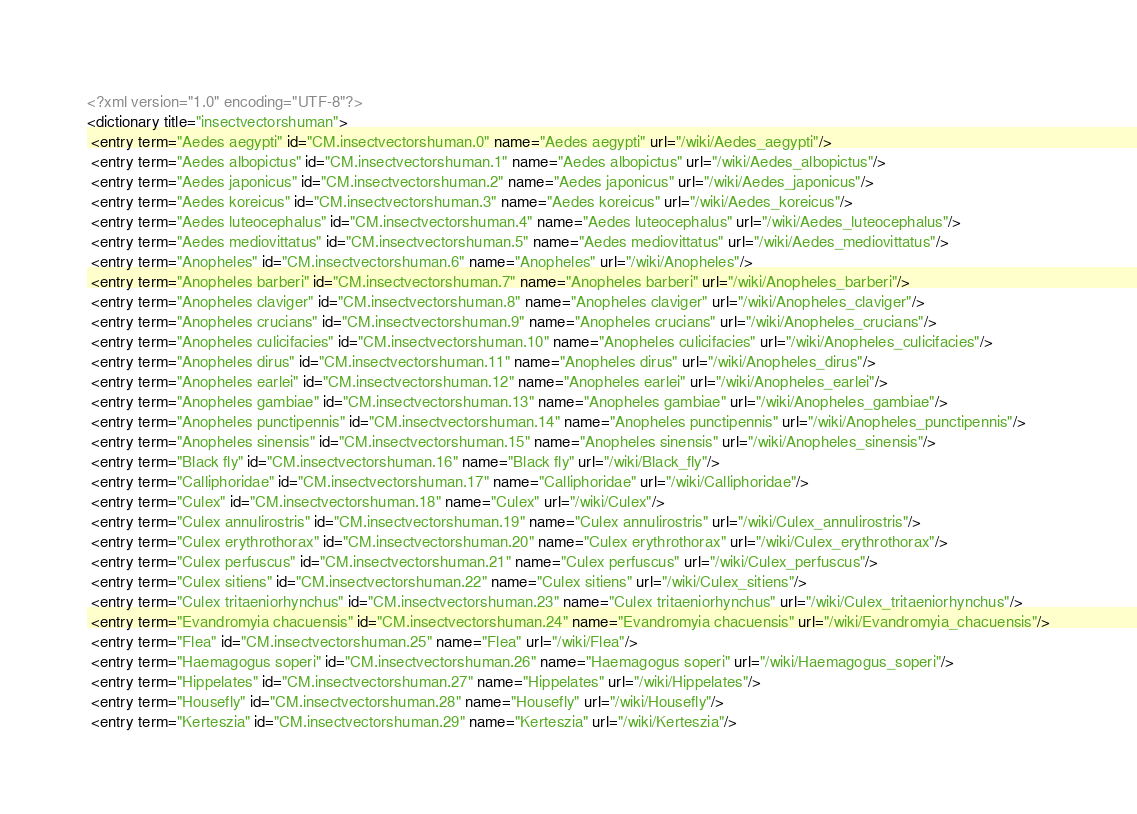Convert code to text. <code><loc_0><loc_0><loc_500><loc_500><_XML_><?xml version="1.0" encoding="UTF-8"?>
<dictionary title="insectvectorshuman">
 <entry term="Aedes aegypti" id="CM.insectvectorshuman.0" name="Aedes aegypti" url="/wiki/Aedes_aegypti"/>
 <entry term="Aedes albopictus" id="CM.insectvectorshuman.1" name="Aedes albopictus" url="/wiki/Aedes_albopictus"/>
 <entry term="Aedes japonicus" id="CM.insectvectorshuman.2" name="Aedes japonicus" url="/wiki/Aedes_japonicus"/>
 <entry term="Aedes koreicus" id="CM.insectvectorshuman.3" name="Aedes koreicus" url="/wiki/Aedes_koreicus"/>
 <entry term="Aedes luteocephalus" id="CM.insectvectorshuman.4" name="Aedes luteocephalus" url="/wiki/Aedes_luteocephalus"/>
 <entry term="Aedes mediovittatus" id="CM.insectvectorshuman.5" name="Aedes mediovittatus" url="/wiki/Aedes_mediovittatus"/>
 <entry term="Anopheles" id="CM.insectvectorshuman.6" name="Anopheles" url="/wiki/Anopheles"/>
 <entry term="Anopheles barberi" id="CM.insectvectorshuman.7" name="Anopheles barberi" url="/wiki/Anopheles_barberi"/>
 <entry term="Anopheles claviger" id="CM.insectvectorshuman.8" name="Anopheles claviger" url="/wiki/Anopheles_claviger"/>
 <entry term="Anopheles crucians" id="CM.insectvectorshuman.9" name="Anopheles crucians" url="/wiki/Anopheles_crucians"/>
 <entry term="Anopheles culicifacies" id="CM.insectvectorshuman.10" name="Anopheles culicifacies" url="/wiki/Anopheles_culicifacies"/>
 <entry term="Anopheles dirus" id="CM.insectvectorshuman.11" name="Anopheles dirus" url="/wiki/Anopheles_dirus"/>
 <entry term="Anopheles earlei" id="CM.insectvectorshuman.12" name="Anopheles earlei" url="/wiki/Anopheles_earlei"/>
 <entry term="Anopheles gambiae" id="CM.insectvectorshuman.13" name="Anopheles gambiae" url="/wiki/Anopheles_gambiae"/>
 <entry term="Anopheles punctipennis" id="CM.insectvectorshuman.14" name="Anopheles punctipennis" url="/wiki/Anopheles_punctipennis"/>
 <entry term="Anopheles sinensis" id="CM.insectvectorshuman.15" name="Anopheles sinensis" url="/wiki/Anopheles_sinensis"/>
 <entry term="Black fly" id="CM.insectvectorshuman.16" name="Black fly" url="/wiki/Black_fly"/>
 <entry term="Calliphoridae" id="CM.insectvectorshuman.17" name="Calliphoridae" url="/wiki/Calliphoridae"/>
 <entry term="Culex" id="CM.insectvectorshuman.18" name="Culex" url="/wiki/Culex"/>
 <entry term="Culex annulirostris" id="CM.insectvectorshuman.19" name="Culex annulirostris" url="/wiki/Culex_annulirostris"/>
 <entry term="Culex erythrothorax" id="CM.insectvectorshuman.20" name="Culex erythrothorax" url="/wiki/Culex_erythrothorax"/>
 <entry term="Culex perfuscus" id="CM.insectvectorshuman.21" name="Culex perfuscus" url="/wiki/Culex_perfuscus"/>
 <entry term="Culex sitiens" id="CM.insectvectorshuman.22" name="Culex sitiens" url="/wiki/Culex_sitiens"/>
 <entry term="Culex tritaeniorhynchus" id="CM.insectvectorshuman.23" name="Culex tritaeniorhynchus" url="/wiki/Culex_tritaeniorhynchus"/>
 <entry term="Evandromyia chacuensis" id="CM.insectvectorshuman.24" name="Evandromyia chacuensis" url="/wiki/Evandromyia_chacuensis"/>
 <entry term="Flea" id="CM.insectvectorshuman.25" name="Flea" url="/wiki/Flea"/>
 <entry term="Haemagogus soperi" id="CM.insectvectorshuman.26" name="Haemagogus soperi" url="/wiki/Haemagogus_soperi"/>
 <entry term="Hippelates" id="CM.insectvectorshuman.27" name="Hippelates" url="/wiki/Hippelates"/>
 <entry term="Housefly" id="CM.insectvectorshuman.28" name="Housefly" url="/wiki/Housefly"/>
 <entry term="Kerteszia" id="CM.insectvectorshuman.29" name="Kerteszia" url="/wiki/Kerteszia"/></code> 